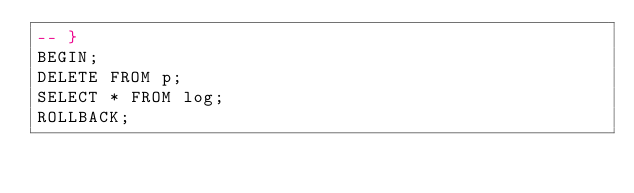Convert code to text. <code><loc_0><loc_0><loc_500><loc_500><_SQL_>-- }
BEGIN;
DELETE FROM p;
SELECT * FROM log;
ROLLBACK;</code> 